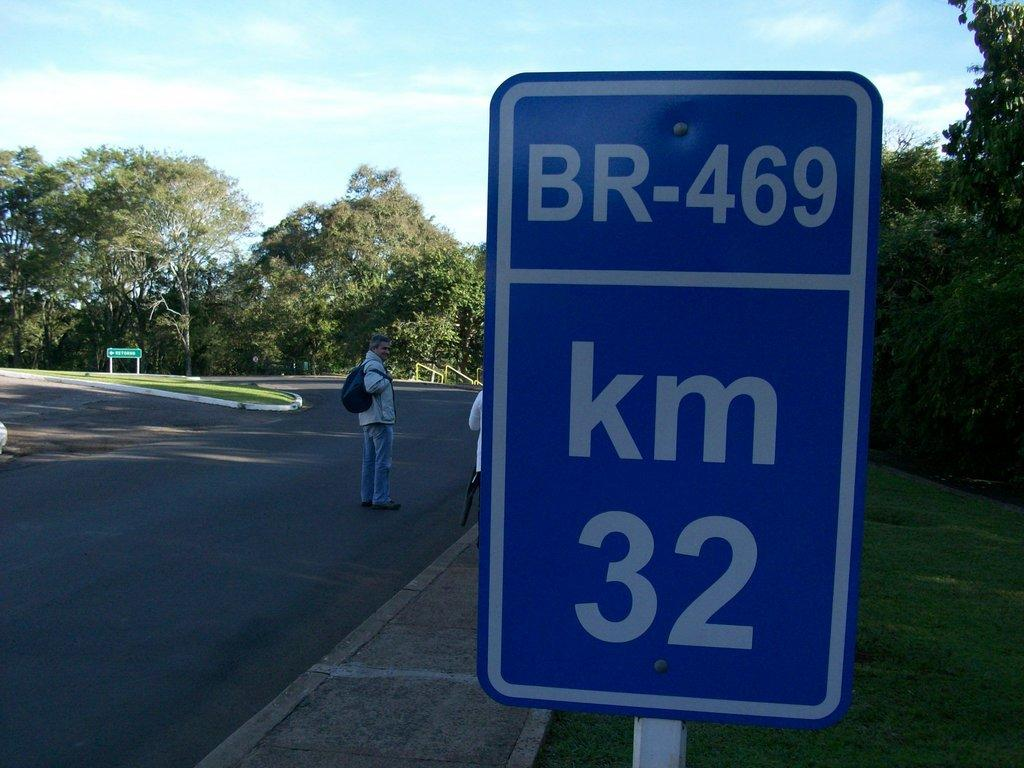<image>
Provide a brief description of the given image. A blue road sign says that BR-469 is in 32 Kilometers. 